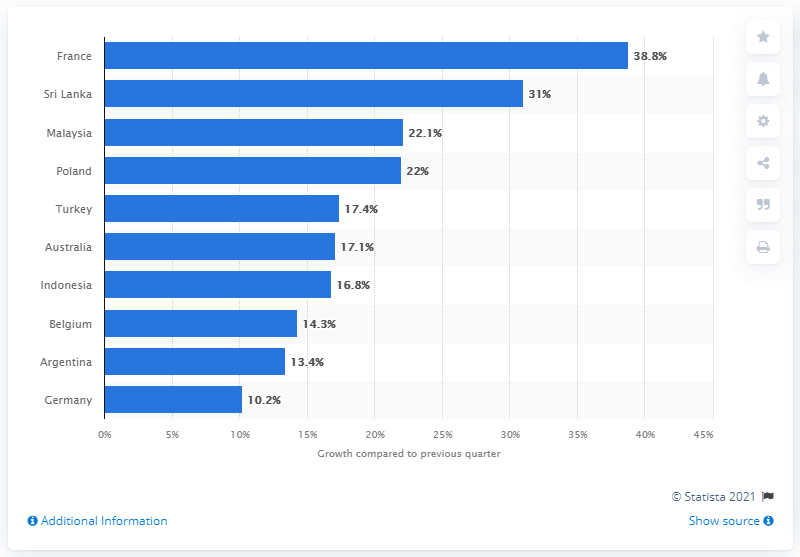Highlight a few significant elements in this photo. According to recent data, France was the fastest growing market for WhatsApp in the first quarter of 2021. WhatsApp experienced a significant increase in downloads in France during the first quarter of 2021, with a reported increase of 38.8%. 